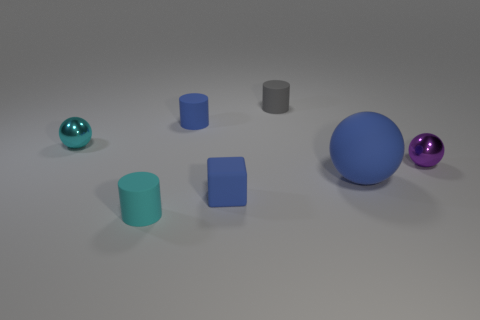There is a tiny blue object that is the same shape as the small cyan matte thing; what is its material?
Make the answer very short. Rubber. There is a small metallic thing to the left of the large blue rubber sphere; is its shape the same as the purple thing?
Your answer should be compact. Yes. Is there a small green metallic cylinder?
Keep it short and to the point. No. The metal thing that is behind the small metallic ball on the right side of the metal thing left of the gray rubber thing is what color?
Your response must be concise. Cyan. Are there an equal number of tiny metallic objects to the right of the cyan metal sphere and purple shiny spheres behind the purple metal object?
Make the answer very short. No. The cyan matte thing that is the same size as the cyan metallic thing is what shape?
Your answer should be compact. Cylinder. Are there any cylinders that have the same color as the big rubber ball?
Keep it short and to the point. Yes. What is the shape of the small blue thing on the left side of the tiny matte cube?
Make the answer very short. Cylinder. What is the color of the tiny rubber block?
Ensure brevity in your answer.  Blue. What is the color of the other small sphere that is the same material as the small purple sphere?
Offer a very short reply. Cyan. 